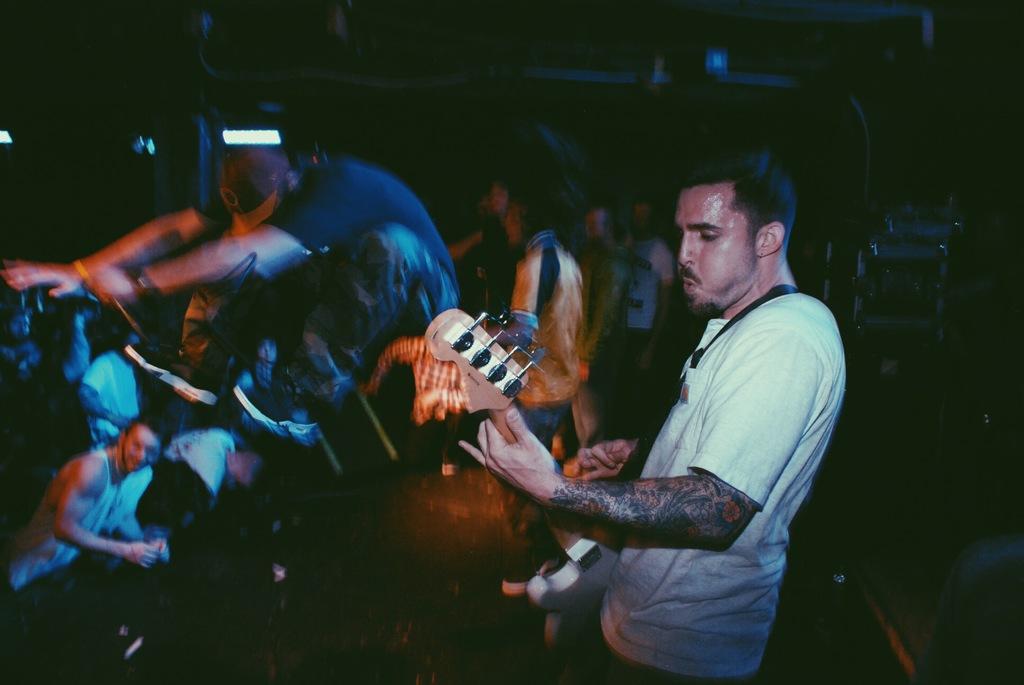Please provide a concise description of this image. In this image I see a man who is holding a guitar and in the background I can see lot of people 